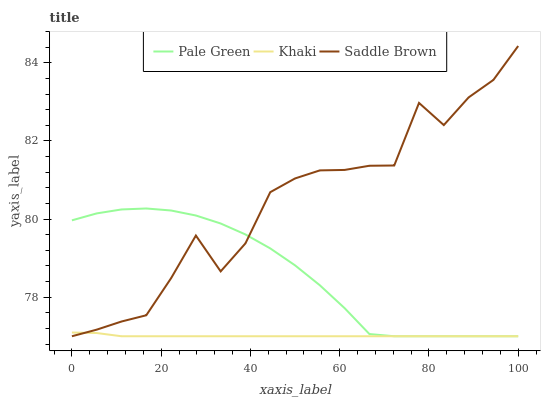Does Khaki have the minimum area under the curve?
Answer yes or no. Yes. Does Saddle Brown have the maximum area under the curve?
Answer yes or no. Yes. Does Saddle Brown have the minimum area under the curve?
Answer yes or no. No. Does Khaki have the maximum area under the curve?
Answer yes or no. No. Is Khaki the smoothest?
Answer yes or no. Yes. Is Saddle Brown the roughest?
Answer yes or no. Yes. Is Saddle Brown the smoothest?
Answer yes or no. No. Is Khaki the roughest?
Answer yes or no. No. Does Pale Green have the lowest value?
Answer yes or no. Yes. Does Saddle Brown have the highest value?
Answer yes or no. Yes. Does Khaki have the highest value?
Answer yes or no. No. Does Pale Green intersect Khaki?
Answer yes or no. Yes. Is Pale Green less than Khaki?
Answer yes or no. No. Is Pale Green greater than Khaki?
Answer yes or no. No. 